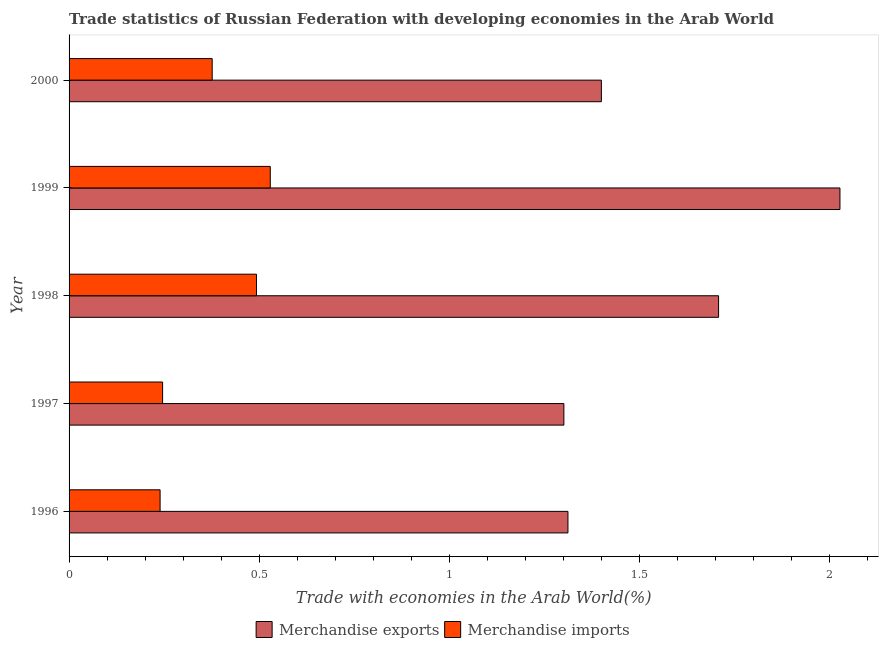Are the number of bars per tick equal to the number of legend labels?
Offer a very short reply. Yes. Are the number of bars on each tick of the Y-axis equal?
Provide a short and direct response. Yes. How many bars are there on the 5th tick from the top?
Provide a short and direct response. 2. What is the label of the 1st group of bars from the top?
Provide a short and direct response. 2000. In how many cases, is the number of bars for a given year not equal to the number of legend labels?
Your response must be concise. 0. What is the merchandise imports in 1996?
Provide a short and direct response. 0.24. Across all years, what is the maximum merchandise imports?
Give a very brief answer. 0.53. Across all years, what is the minimum merchandise imports?
Provide a short and direct response. 0.24. In which year was the merchandise exports maximum?
Offer a terse response. 1999. What is the total merchandise exports in the graph?
Give a very brief answer. 7.75. What is the difference between the merchandise imports in 1996 and that in 1999?
Offer a terse response. -0.29. What is the difference between the merchandise imports in 1997 and the merchandise exports in 1996?
Make the answer very short. -1.07. What is the average merchandise imports per year?
Provide a short and direct response. 0.38. In the year 1998, what is the difference between the merchandise imports and merchandise exports?
Your answer should be very brief. -1.22. In how many years, is the merchandise imports greater than 0.6 %?
Your answer should be very brief. 0. What is the ratio of the merchandise imports in 1997 to that in 2000?
Make the answer very short. 0.65. Is the merchandise exports in 1997 less than that in 2000?
Ensure brevity in your answer.  Yes. Is the difference between the merchandise exports in 1996 and 1998 greater than the difference between the merchandise imports in 1996 and 1998?
Provide a short and direct response. No. What is the difference between the highest and the second highest merchandise imports?
Provide a succinct answer. 0.04. What is the difference between the highest and the lowest merchandise exports?
Your answer should be compact. 0.73. In how many years, is the merchandise imports greater than the average merchandise imports taken over all years?
Provide a short and direct response. 2. Is the sum of the merchandise imports in 1998 and 1999 greater than the maximum merchandise exports across all years?
Give a very brief answer. No. What does the 2nd bar from the top in 1997 represents?
Your answer should be compact. Merchandise exports. How many bars are there?
Provide a short and direct response. 10. How many years are there in the graph?
Your answer should be very brief. 5. Does the graph contain any zero values?
Provide a succinct answer. No. How are the legend labels stacked?
Your response must be concise. Horizontal. What is the title of the graph?
Keep it short and to the point. Trade statistics of Russian Federation with developing economies in the Arab World. Does "Unregistered firms" appear as one of the legend labels in the graph?
Give a very brief answer. No. What is the label or title of the X-axis?
Offer a very short reply. Trade with economies in the Arab World(%). What is the label or title of the Y-axis?
Provide a succinct answer. Year. What is the Trade with economies in the Arab World(%) in Merchandise exports in 1996?
Your answer should be very brief. 1.31. What is the Trade with economies in the Arab World(%) of Merchandise imports in 1996?
Your answer should be compact. 0.24. What is the Trade with economies in the Arab World(%) in Merchandise exports in 1997?
Offer a very short reply. 1.3. What is the Trade with economies in the Arab World(%) of Merchandise imports in 1997?
Offer a terse response. 0.25. What is the Trade with economies in the Arab World(%) of Merchandise exports in 1998?
Give a very brief answer. 1.71. What is the Trade with economies in the Arab World(%) of Merchandise imports in 1998?
Make the answer very short. 0.49. What is the Trade with economies in the Arab World(%) of Merchandise exports in 1999?
Make the answer very short. 2.03. What is the Trade with economies in the Arab World(%) in Merchandise imports in 1999?
Your response must be concise. 0.53. What is the Trade with economies in the Arab World(%) of Merchandise exports in 2000?
Provide a short and direct response. 1.4. What is the Trade with economies in the Arab World(%) of Merchandise imports in 2000?
Offer a very short reply. 0.38. Across all years, what is the maximum Trade with economies in the Arab World(%) in Merchandise exports?
Offer a very short reply. 2.03. Across all years, what is the maximum Trade with economies in the Arab World(%) of Merchandise imports?
Your response must be concise. 0.53. Across all years, what is the minimum Trade with economies in the Arab World(%) of Merchandise exports?
Make the answer very short. 1.3. Across all years, what is the minimum Trade with economies in the Arab World(%) of Merchandise imports?
Keep it short and to the point. 0.24. What is the total Trade with economies in the Arab World(%) of Merchandise exports in the graph?
Ensure brevity in your answer.  7.75. What is the total Trade with economies in the Arab World(%) of Merchandise imports in the graph?
Provide a succinct answer. 1.88. What is the difference between the Trade with economies in the Arab World(%) in Merchandise exports in 1996 and that in 1997?
Your answer should be compact. 0.01. What is the difference between the Trade with economies in the Arab World(%) in Merchandise imports in 1996 and that in 1997?
Give a very brief answer. -0.01. What is the difference between the Trade with economies in the Arab World(%) of Merchandise exports in 1996 and that in 1998?
Your response must be concise. -0.4. What is the difference between the Trade with economies in the Arab World(%) in Merchandise imports in 1996 and that in 1998?
Keep it short and to the point. -0.25. What is the difference between the Trade with economies in the Arab World(%) of Merchandise exports in 1996 and that in 1999?
Your answer should be very brief. -0.72. What is the difference between the Trade with economies in the Arab World(%) in Merchandise imports in 1996 and that in 1999?
Your answer should be very brief. -0.29. What is the difference between the Trade with economies in the Arab World(%) in Merchandise exports in 1996 and that in 2000?
Give a very brief answer. -0.09. What is the difference between the Trade with economies in the Arab World(%) in Merchandise imports in 1996 and that in 2000?
Make the answer very short. -0.14. What is the difference between the Trade with economies in the Arab World(%) of Merchandise exports in 1997 and that in 1998?
Provide a short and direct response. -0.41. What is the difference between the Trade with economies in the Arab World(%) of Merchandise imports in 1997 and that in 1998?
Provide a succinct answer. -0.25. What is the difference between the Trade with economies in the Arab World(%) of Merchandise exports in 1997 and that in 1999?
Offer a very short reply. -0.73. What is the difference between the Trade with economies in the Arab World(%) of Merchandise imports in 1997 and that in 1999?
Provide a succinct answer. -0.28. What is the difference between the Trade with economies in the Arab World(%) of Merchandise exports in 1997 and that in 2000?
Give a very brief answer. -0.1. What is the difference between the Trade with economies in the Arab World(%) in Merchandise imports in 1997 and that in 2000?
Provide a succinct answer. -0.13. What is the difference between the Trade with economies in the Arab World(%) of Merchandise exports in 1998 and that in 1999?
Make the answer very short. -0.32. What is the difference between the Trade with economies in the Arab World(%) in Merchandise imports in 1998 and that in 1999?
Your answer should be very brief. -0.04. What is the difference between the Trade with economies in the Arab World(%) of Merchandise exports in 1998 and that in 2000?
Make the answer very short. 0.31. What is the difference between the Trade with economies in the Arab World(%) of Merchandise imports in 1998 and that in 2000?
Offer a very short reply. 0.12. What is the difference between the Trade with economies in the Arab World(%) in Merchandise exports in 1999 and that in 2000?
Your answer should be very brief. 0.63. What is the difference between the Trade with economies in the Arab World(%) in Merchandise imports in 1999 and that in 2000?
Make the answer very short. 0.15. What is the difference between the Trade with economies in the Arab World(%) in Merchandise exports in 1996 and the Trade with economies in the Arab World(%) in Merchandise imports in 1997?
Offer a terse response. 1.07. What is the difference between the Trade with economies in the Arab World(%) of Merchandise exports in 1996 and the Trade with economies in the Arab World(%) of Merchandise imports in 1998?
Provide a short and direct response. 0.82. What is the difference between the Trade with economies in the Arab World(%) of Merchandise exports in 1996 and the Trade with economies in the Arab World(%) of Merchandise imports in 1999?
Your answer should be compact. 0.78. What is the difference between the Trade with economies in the Arab World(%) of Merchandise exports in 1996 and the Trade with economies in the Arab World(%) of Merchandise imports in 2000?
Offer a terse response. 0.94. What is the difference between the Trade with economies in the Arab World(%) in Merchandise exports in 1997 and the Trade with economies in the Arab World(%) in Merchandise imports in 1998?
Offer a very short reply. 0.81. What is the difference between the Trade with economies in the Arab World(%) in Merchandise exports in 1997 and the Trade with economies in the Arab World(%) in Merchandise imports in 1999?
Ensure brevity in your answer.  0.77. What is the difference between the Trade with economies in the Arab World(%) in Merchandise exports in 1997 and the Trade with economies in the Arab World(%) in Merchandise imports in 2000?
Provide a succinct answer. 0.93. What is the difference between the Trade with economies in the Arab World(%) in Merchandise exports in 1998 and the Trade with economies in the Arab World(%) in Merchandise imports in 1999?
Ensure brevity in your answer.  1.18. What is the difference between the Trade with economies in the Arab World(%) of Merchandise exports in 1998 and the Trade with economies in the Arab World(%) of Merchandise imports in 2000?
Offer a terse response. 1.33. What is the difference between the Trade with economies in the Arab World(%) in Merchandise exports in 1999 and the Trade with economies in the Arab World(%) in Merchandise imports in 2000?
Provide a succinct answer. 1.65. What is the average Trade with economies in the Arab World(%) of Merchandise exports per year?
Keep it short and to the point. 1.55. What is the average Trade with economies in the Arab World(%) in Merchandise imports per year?
Offer a very short reply. 0.38. In the year 1996, what is the difference between the Trade with economies in the Arab World(%) of Merchandise exports and Trade with economies in the Arab World(%) of Merchandise imports?
Give a very brief answer. 1.07. In the year 1997, what is the difference between the Trade with economies in the Arab World(%) of Merchandise exports and Trade with economies in the Arab World(%) of Merchandise imports?
Provide a short and direct response. 1.06. In the year 1998, what is the difference between the Trade with economies in the Arab World(%) of Merchandise exports and Trade with economies in the Arab World(%) of Merchandise imports?
Keep it short and to the point. 1.22. In the year 1999, what is the difference between the Trade with economies in the Arab World(%) in Merchandise exports and Trade with economies in the Arab World(%) in Merchandise imports?
Your answer should be compact. 1.5. In the year 2000, what is the difference between the Trade with economies in the Arab World(%) in Merchandise exports and Trade with economies in the Arab World(%) in Merchandise imports?
Your response must be concise. 1.02. What is the ratio of the Trade with economies in the Arab World(%) of Merchandise exports in 1996 to that in 1997?
Make the answer very short. 1.01. What is the ratio of the Trade with economies in the Arab World(%) of Merchandise imports in 1996 to that in 1997?
Your response must be concise. 0.97. What is the ratio of the Trade with economies in the Arab World(%) in Merchandise exports in 1996 to that in 1998?
Your answer should be compact. 0.77. What is the ratio of the Trade with economies in the Arab World(%) in Merchandise imports in 1996 to that in 1998?
Your answer should be compact. 0.49. What is the ratio of the Trade with economies in the Arab World(%) of Merchandise exports in 1996 to that in 1999?
Offer a very short reply. 0.65. What is the ratio of the Trade with economies in the Arab World(%) in Merchandise imports in 1996 to that in 1999?
Give a very brief answer. 0.45. What is the ratio of the Trade with economies in the Arab World(%) in Merchandise exports in 1996 to that in 2000?
Make the answer very short. 0.94. What is the ratio of the Trade with economies in the Arab World(%) of Merchandise imports in 1996 to that in 2000?
Make the answer very short. 0.64. What is the ratio of the Trade with economies in the Arab World(%) in Merchandise exports in 1997 to that in 1998?
Keep it short and to the point. 0.76. What is the ratio of the Trade with economies in the Arab World(%) of Merchandise imports in 1997 to that in 1998?
Offer a very short reply. 0.5. What is the ratio of the Trade with economies in the Arab World(%) in Merchandise exports in 1997 to that in 1999?
Give a very brief answer. 0.64. What is the ratio of the Trade with economies in the Arab World(%) of Merchandise imports in 1997 to that in 1999?
Keep it short and to the point. 0.46. What is the ratio of the Trade with economies in the Arab World(%) of Merchandise exports in 1997 to that in 2000?
Offer a very short reply. 0.93. What is the ratio of the Trade with economies in the Arab World(%) in Merchandise imports in 1997 to that in 2000?
Give a very brief answer. 0.65. What is the ratio of the Trade with economies in the Arab World(%) of Merchandise exports in 1998 to that in 1999?
Make the answer very short. 0.84. What is the ratio of the Trade with economies in the Arab World(%) in Merchandise imports in 1998 to that in 1999?
Ensure brevity in your answer.  0.93. What is the ratio of the Trade with economies in the Arab World(%) in Merchandise exports in 1998 to that in 2000?
Your answer should be very brief. 1.22. What is the ratio of the Trade with economies in the Arab World(%) of Merchandise imports in 1998 to that in 2000?
Ensure brevity in your answer.  1.31. What is the ratio of the Trade with economies in the Arab World(%) in Merchandise exports in 1999 to that in 2000?
Provide a short and direct response. 1.45. What is the ratio of the Trade with economies in the Arab World(%) of Merchandise imports in 1999 to that in 2000?
Give a very brief answer. 1.41. What is the difference between the highest and the second highest Trade with economies in the Arab World(%) of Merchandise exports?
Provide a succinct answer. 0.32. What is the difference between the highest and the second highest Trade with economies in the Arab World(%) in Merchandise imports?
Offer a very short reply. 0.04. What is the difference between the highest and the lowest Trade with economies in the Arab World(%) of Merchandise exports?
Ensure brevity in your answer.  0.73. What is the difference between the highest and the lowest Trade with economies in the Arab World(%) in Merchandise imports?
Your answer should be very brief. 0.29. 